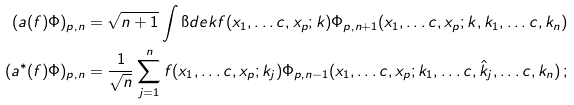Convert formula to latex. <formula><loc_0><loc_0><loc_500><loc_500>( a ( f ) \Phi ) _ { p , n } & = \sqrt { n + 1 } \int \i d e { k } f ( x _ { 1 } , \dots c , x _ { p } ; k ) \Phi _ { p , n + 1 } ( x _ { 1 } , \dots c , x _ { p } ; k , k _ { 1 } , \dots c , k _ { n } ) \\ ( a ^ { * } ( f ) \Phi ) _ { p , n } & = \frac { 1 } { \sqrt { n } } \sum _ { j = 1 } ^ { n } f ( x _ { 1 } , \dots c , x _ { p } ; k _ { j } ) \Phi _ { p , n - 1 } ( x _ { 1 } , \dots c , x _ { p } ; k _ { 1 } , \dots c , \hat { k } _ { j } , \dots c , k _ { n } ) \, ;</formula> 